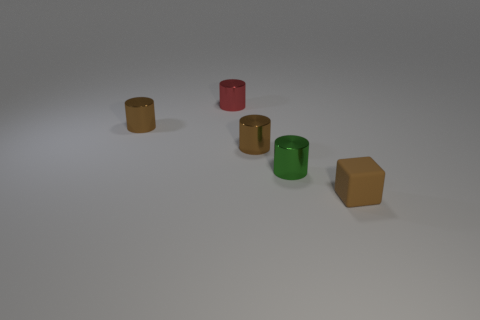Subtract all tiny green cylinders. How many cylinders are left? 3 Subtract all green cylinders. How many cylinders are left? 3 Subtract 1 cubes. How many cubes are left? 0 Subtract all brown cylinders. Subtract all gray cubes. How many cylinders are left? 2 Subtract all yellow cylinders. How many blue cubes are left? 0 Add 4 cubes. How many cubes are left? 5 Add 1 blue matte cubes. How many blue matte cubes exist? 1 Add 3 brown blocks. How many objects exist? 8 Subtract 1 red cylinders. How many objects are left? 4 Subtract all blocks. How many objects are left? 4 